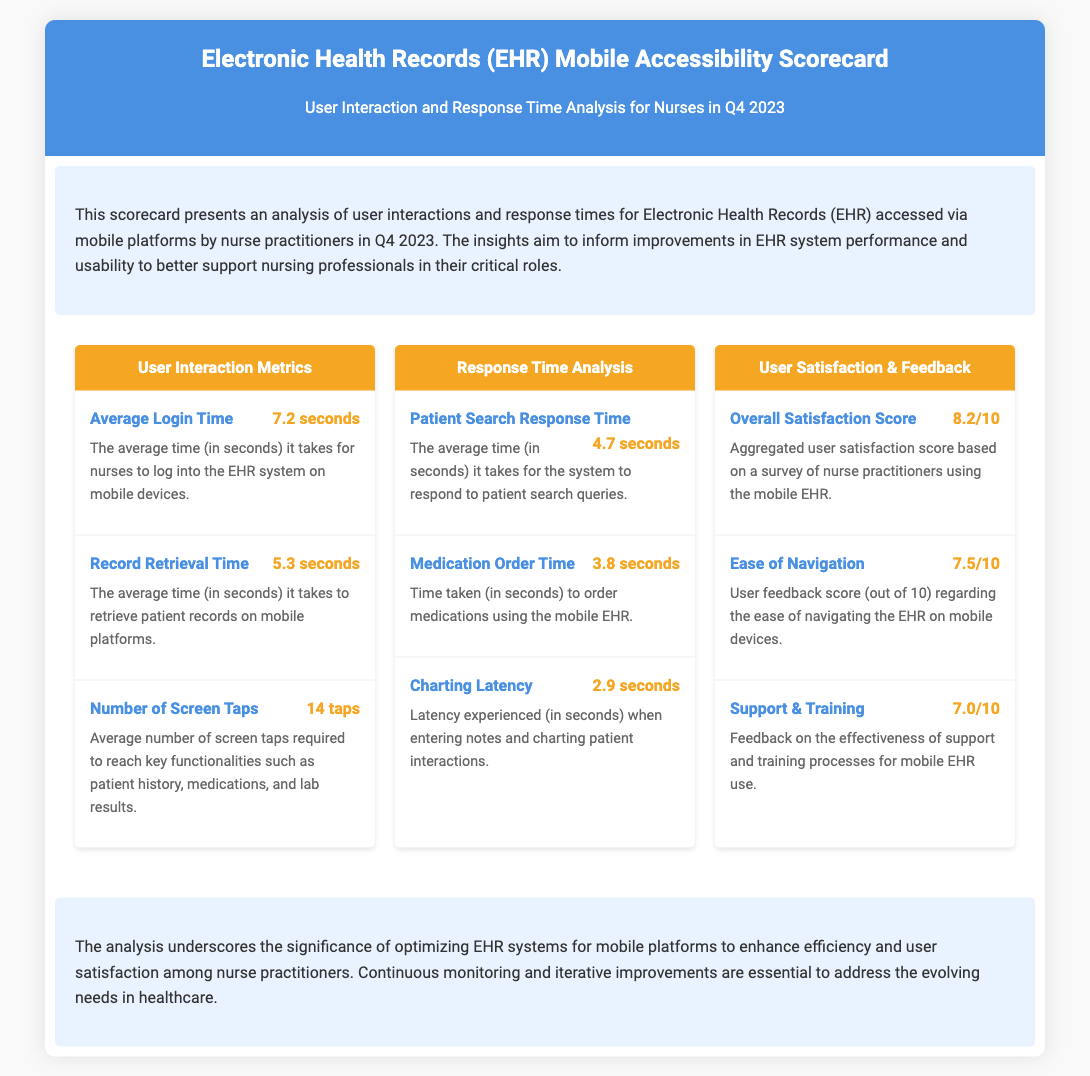What is the average login time? The average login time is defined in the document as the duration it takes for nurses to log into the EHR system on mobile devices.
Answer: 7.2 seconds What is the patient search response time? The patient search response time indicates how long it takes for the system to respond to patient search queries on mobile platforms.
Answer: 4.7 seconds What is the overall satisfaction score given by users? The overall satisfaction score reflects the aggregated user satisfaction based on a survey conducted with nurse practitioners.
Answer: 8.2/10 How many screen taps are required to access key functionalities? The number of screen taps refers to the average interaction needed to reach essential features such as patient history and lab results within the EHR.
Answer: 14 taps What is the latency experienced during charting? The latency experienced when entering notes and charting indicates the delay felt by nurse practitioners while documenting patient interactions.
Answer: 2.9 seconds Which metric has the lowest score? The metric with the lowest score reflects user feedback on the support and training provided for mobile EHR use, highlighting areas for potential improvement.
Answer: 7.0/10 What was the response time for medication orders? The response time for ordering medications is detailed in the document as the time taken to process medication requests through the mobile EHR.
Answer: 3.8 seconds What is the description of the user satisfaction score? The user satisfaction score is described as the aggregated feedback collected from nurse practitioners who use the mobile EHR system.
Answer: Aggregated user satisfaction score based on a survey What improvement does the conclusion suggest? The conclusion emphasizes the importance of optimizing EHR systems for better efficiency and user satisfaction among nurse practitioners.
Answer: Optimizing EHR systems for mobile platforms 